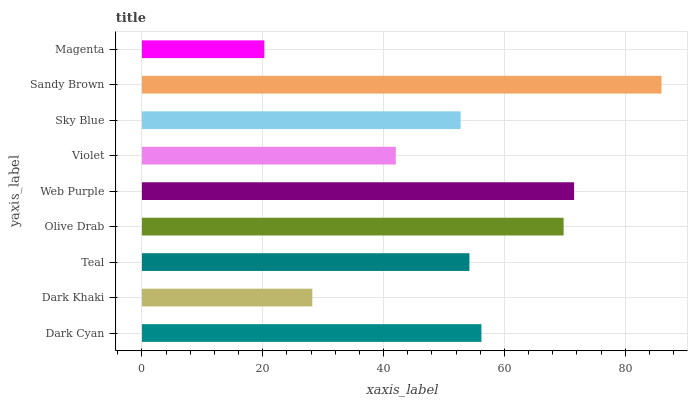Is Magenta the minimum?
Answer yes or no. Yes. Is Sandy Brown the maximum?
Answer yes or no. Yes. Is Dark Khaki the minimum?
Answer yes or no. No. Is Dark Khaki the maximum?
Answer yes or no. No. Is Dark Cyan greater than Dark Khaki?
Answer yes or no. Yes. Is Dark Khaki less than Dark Cyan?
Answer yes or no. Yes. Is Dark Khaki greater than Dark Cyan?
Answer yes or no. No. Is Dark Cyan less than Dark Khaki?
Answer yes or no. No. Is Teal the high median?
Answer yes or no. Yes. Is Teal the low median?
Answer yes or no. Yes. Is Magenta the high median?
Answer yes or no. No. Is Web Purple the low median?
Answer yes or no. No. 